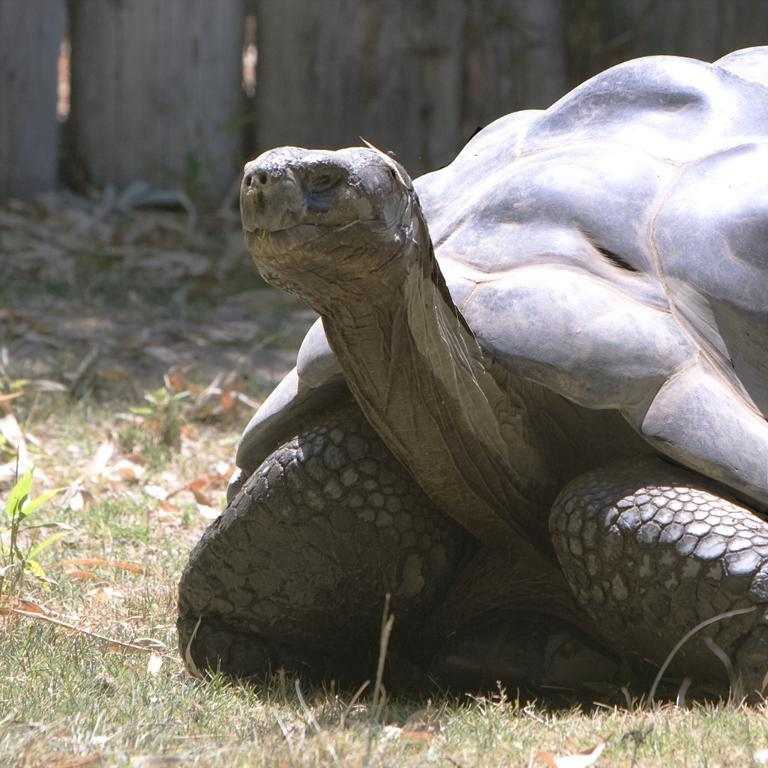What type of animal is in the image? There is a big tortoise in the image. What can be seen on the left side of the image? There is grass on the left side of the image. What type of material is used for the fencing at the top of the image? The fencing at the top of the image is made of wood. What type of reward is the tortoise receiving in the image? There is no indication in the image that the tortoise is receiving a reward. 